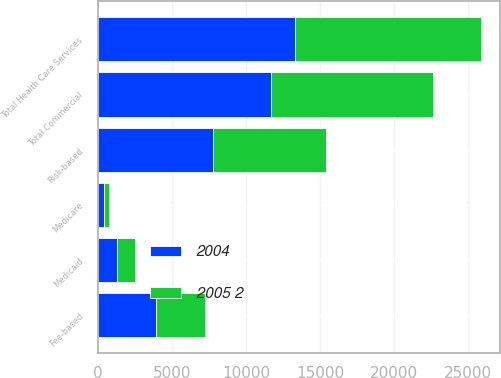Convert chart. <chart><loc_0><loc_0><loc_500><loc_500><stacked_bar_chart><ecel><fcel>Risk-based<fcel>Fee-based<fcel>Total Commercial<fcel>Medicare<fcel>Medicaid<fcel>Total Health Care Services<nl><fcel>2004<fcel>7765<fcel>3895<fcel>11660<fcel>395<fcel>1250<fcel>13305<nl><fcel>2005 2<fcel>7655<fcel>3305<fcel>10960<fcel>330<fcel>1260<fcel>12550<nl></chart> 